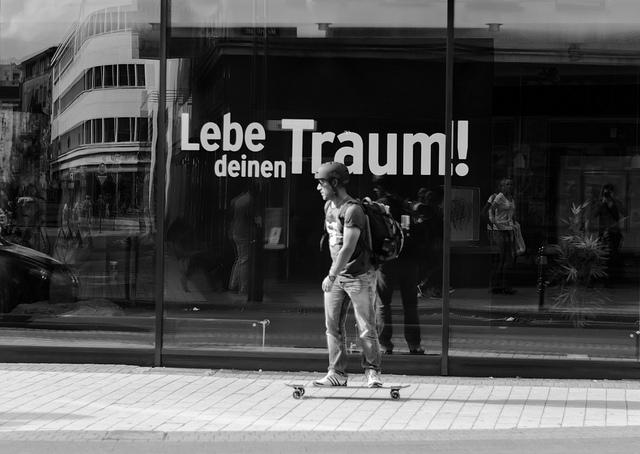What is the language of the sign?
Short answer required. German. What's on the man's head?
Write a very short answer. Helmet. What does the sign say on the glass window?
Keep it brief. Lebe deinen traum!. 